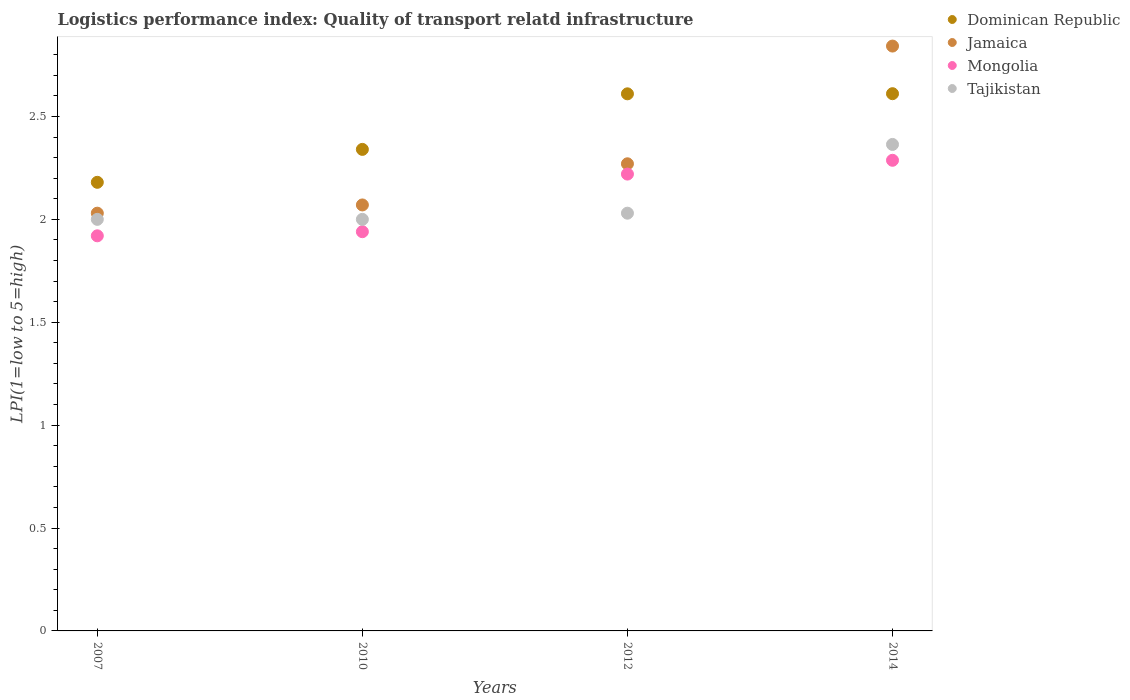How many different coloured dotlines are there?
Keep it short and to the point. 4. Is the number of dotlines equal to the number of legend labels?
Offer a terse response. Yes. What is the logistics performance index in Tajikistan in 2014?
Your answer should be very brief. 2.36. Across all years, what is the maximum logistics performance index in Dominican Republic?
Provide a short and direct response. 2.61. Across all years, what is the minimum logistics performance index in Mongolia?
Offer a very short reply. 1.92. In which year was the logistics performance index in Mongolia maximum?
Your answer should be compact. 2014. In which year was the logistics performance index in Dominican Republic minimum?
Offer a terse response. 2007. What is the total logistics performance index in Jamaica in the graph?
Make the answer very short. 9.21. What is the difference between the logistics performance index in Mongolia in 2007 and that in 2010?
Offer a very short reply. -0.02. What is the difference between the logistics performance index in Dominican Republic in 2014 and the logistics performance index in Jamaica in 2007?
Offer a very short reply. 0.58. What is the average logistics performance index in Jamaica per year?
Your answer should be very brief. 2.3. In the year 2010, what is the difference between the logistics performance index in Dominican Republic and logistics performance index in Tajikistan?
Your answer should be compact. 0.34. In how many years, is the logistics performance index in Tajikistan greater than 0.6?
Make the answer very short. 4. What is the ratio of the logistics performance index in Mongolia in 2007 to that in 2014?
Provide a short and direct response. 0.84. What is the difference between the highest and the second highest logistics performance index in Tajikistan?
Your answer should be compact. 0.33. What is the difference between the highest and the lowest logistics performance index in Tajikistan?
Give a very brief answer. 0.36. In how many years, is the logistics performance index in Tajikistan greater than the average logistics performance index in Tajikistan taken over all years?
Provide a succinct answer. 1. Is the sum of the logistics performance index in Tajikistan in 2007 and 2014 greater than the maximum logistics performance index in Dominican Republic across all years?
Your answer should be compact. Yes. Does the logistics performance index in Tajikistan monotonically increase over the years?
Keep it short and to the point. No. Is the logistics performance index in Dominican Republic strictly greater than the logistics performance index in Tajikistan over the years?
Provide a short and direct response. Yes. How many dotlines are there?
Your response must be concise. 4. Are the values on the major ticks of Y-axis written in scientific E-notation?
Ensure brevity in your answer.  No. Does the graph contain any zero values?
Keep it short and to the point. No. Does the graph contain grids?
Offer a terse response. No. Where does the legend appear in the graph?
Make the answer very short. Top right. What is the title of the graph?
Ensure brevity in your answer.  Logistics performance index: Quality of transport relatd infrastructure. Does "Mali" appear as one of the legend labels in the graph?
Offer a terse response. No. What is the label or title of the X-axis?
Your answer should be very brief. Years. What is the label or title of the Y-axis?
Offer a terse response. LPI(1=low to 5=high). What is the LPI(1=low to 5=high) of Dominican Republic in 2007?
Ensure brevity in your answer.  2.18. What is the LPI(1=low to 5=high) of Jamaica in 2007?
Keep it short and to the point. 2.03. What is the LPI(1=low to 5=high) in Mongolia in 2007?
Your answer should be very brief. 1.92. What is the LPI(1=low to 5=high) of Dominican Republic in 2010?
Make the answer very short. 2.34. What is the LPI(1=low to 5=high) of Jamaica in 2010?
Give a very brief answer. 2.07. What is the LPI(1=low to 5=high) in Mongolia in 2010?
Make the answer very short. 1.94. What is the LPI(1=low to 5=high) of Tajikistan in 2010?
Ensure brevity in your answer.  2. What is the LPI(1=low to 5=high) in Dominican Republic in 2012?
Provide a short and direct response. 2.61. What is the LPI(1=low to 5=high) in Jamaica in 2012?
Your answer should be compact. 2.27. What is the LPI(1=low to 5=high) of Mongolia in 2012?
Your answer should be compact. 2.22. What is the LPI(1=low to 5=high) of Tajikistan in 2012?
Offer a terse response. 2.03. What is the LPI(1=low to 5=high) of Dominican Republic in 2014?
Your answer should be very brief. 2.61. What is the LPI(1=low to 5=high) of Jamaica in 2014?
Offer a terse response. 2.84. What is the LPI(1=low to 5=high) of Mongolia in 2014?
Keep it short and to the point. 2.29. What is the LPI(1=low to 5=high) of Tajikistan in 2014?
Make the answer very short. 2.36. Across all years, what is the maximum LPI(1=low to 5=high) in Dominican Republic?
Provide a succinct answer. 2.61. Across all years, what is the maximum LPI(1=low to 5=high) of Jamaica?
Your answer should be very brief. 2.84. Across all years, what is the maximum LPI(1=low to 5=high) in Mongolia?
Offer a very short reply. 2.29. Across all years, what is the maximum LPI(1=low to 5=high) in Tajikistan?
Offer a very short reply. 2.36. Across all years, what is the minimum LPI(1=low to 5=high) in Dominican Republic?
Keep it short and to the point. 2.18. Across all years, what is the minimum LPI(1=low to 5=high) of Jamaica?
Give a very brief answer. 2.03. Across all years, what is the minimum LPI(1=low to 5=high) of Mongolia?
Your answer should be very brief. 1.92. Across all years, what is the minimum LPI(1=low to 5=high) of Tajikistan?
Provide a short and direct response. 2. What is the total LPI(1=low to 5=high) of Dominican Republic in the graph?
Provide a succinct answer. 9.74. What is the total LPI(1=low to 5=high) of Jamaica in the graph?
Provide a succinct answer. 9.21. What is the total LPI(1=low to 5=high) of Mongolia in the graph?
Ensure brevity in your answer.  8.37. What is the total LPI(1=low to 5=high) in Tajikistan in the graph?
Provide a short and direct response. 8.39. What is the difference between the LPI(1=low to 5=high) in Dominican Republic in 2007 and that in 2010?
Keep it short and to the point. -0.16. What is the difference between the LPI(1=low to 5=high) in Jamaica in 2007 and that in 2010?
Offer a very short reply. -0.04. What is the difference between the LPI(1=low to 5=high) in Mongolia in 2007 and that in 2010?
Provide a short and direct response. -0.02. What is the difference between the LPI(1=low to 5=high) in Dominican Republic in 2007 and that in 2012?
Keep it short and to the point. -0.43. What is the difference between the LPI(1=low to 5=high) of Jamaica in 2007 and that in 2012?
Offer a very short reply. -0.24. What is the difference between the LPI(1=low to 5=high) of Mongolia in 2007 and that in 2012?
Offer a terse response. -0.3. What is the difference between the LPI(1=low to 5=high) in Tajikistan in 2007 and that in 2012?
Your answer should be very brief. -0.03. What is the difference between the LPI(1=low to 5=high) in Dominican Republic in 2007 and that in 2014?
Your answer should be compact. -0.43. What is the difference between the LPI(1=low to 5=high) in Jamaica in 2007 and that in 2014?
Your answer should be very brief. -0.81. What is the difference between the LPI(1=low to 5=high) in Mongolia in 2007 and that in 2014?
Your answer should be compact. -0.37. What is the difference between the LPI(1=low to 5=high) in Tajikistan in 2007 and that in 2014?
Give a very brief answer. -0.36. What is the difference between the LPI(1=low to 5=high) in Dominican Republic in 2010 and that in 2012?
Ensure brevity in your answer.  -0.27. What is the difference between the LPI(1=low to 5=high) of Mongolia in 2010 and that in 2012?
Your answer should be compact. -0.28. What is the difference between the LPI(1=low to 5=high) of Tajikistan in 2010 and that in 2012?
Make the answer very short. -0.03. What is the difference between the LPI(1=low to 5=high) in Dominican Republic in 2010 and that in 2014?
Provide a short and direct response. -0.27. What is the difference between the LPI(1=low to 5=high) in Jamaica in 2010 and that in 2014?
Ensure brevity in your answer.  -0.77. What is the difference between the LPI(1=low to 5=high) in Mongolia in 2010 and that in 2014?
Your answer should be very brief. -0.35. What is the difference between the LPI(1=low to 5=high) of Tajikistan in 2010 and that in 2014?
Give a very brief answer. -0.36. What is the difference between the LPI(1=low to 5=high) in Dominican Republic in 2012 and that in 2014?
Make the answer very short. -0. What is the difference between the LPI(1=low to 5=high) of Jamaica in 2012 and that in 2014?
Provide a succinct answer. -0.57. What is the difference between the LPI(1=low to 5=high) of Mongolia in 2012 and that in 2014?
Give a very brief answer. -0.07. What is the difference between the LPI(1=low to 5=high) of Tajikistan in 2012 and that in 2014?
Provide a succinct answer. -0.33. What is the difference between the LPI(1=low to 5=high) of Dominican Republic in 2007 and the LPI(1=low to 5=high) of Jamaica in 2010?
Ensure brevity in your answer.  0.11. What is the difference between the LPI(1=low to 5=high) of Dominican Republic in 2007 and the LPI(1=low to 5=high) of Mongolia in 2010?
Give a very brief answer. 0.24. What is the difference between the LPI(1=low to 5=high) of Dominican Republic in 2007 and the LPI(1=low to 5=high) of Tajikistan in 2010?
Offer a very short reply. 0.18. What is the difference between the LPI(1=low to 5=high) of Jamaica in 2007 and the LPI(1=low to 5=high) of Mongolia in 2010?
Ensure brevity in your answer.  0.09. What is the difference between the LPI(1=low to 5=high) in Mongolia in 2007 and the LPI(1=low to 5=high) in Tajikistan in 2010?
Give a very brief answer. -0.08. What is the difference between the LPI(1=low to 5=high) in Dominican Republic in 2007 and the LPI(1=low to 5=high) in Jamaica in 2012?
Your answer should be compact. -0.09. What is the difference between the LPI(1=low to 5=high) of Dominican Republic in 2007 and the LPI(1=low to 5=high) of Mongolia in 2012?
Your answer should be very brief. -0.04. What is the difference between the LPI(1=low to 5=high) of Dominican Republic in 2007 and the LPI(1=low to 5=high) of Tajikistan in 2012?
Offer a terse response. 0.15. What is the difference between the LPI(1=low to 5=high) in Jamaica in 2007 and the LPI(1=low to 5=high) in Mongolia in 2012?
Give a very brief answer. -0.19. What is the difference between the LPI(1=low to 5=high) in Mongolia in 2007 and the LPI(1=low to 5=high) in Tajikistan in 2012?
Your response must be concise. -0.11. What is the difference between the LPI(1=low to 5=high) of Dominican Republic in 2007 and the LPI(1=low to 5=high) of Jamaica in 2014?
Your answer should be compact. -0.66. What is the difference between the LPI(1=low to 5=high) in Dominican Republic in 2007 and the LPI(1=low to 5=high) in Mongolia in 2014?
Your answer should be very brief. -0.11. What is the difference between the LPI(1=low to 5=high) in Dominican Republic in 2007 and the LPI(1=low to 5=high) in Tajikistan in 2014?
Offer a very short reply. -0.18. What is the difference between the LPI(1=low to 5=high) in Jamaica in 2007 and the LPI(1=low to 5=high) in Mongolia in 2014?
Your answer should be compact. -0.26. What is the difference between the LPI(1=low to 5=high) in Jamaica in 2007 and the LPI(1=low to 5=high) in Tajikistan in 2014?
Your answer should be compact. -0.33. What is the difference between the LPI(1=low to 5=high) of Mongolia in 2007 and the LPI(1=low to 5=high) of Tajikistan in 2014?
Your answer should be compact. -0.44. What is the difference between the LPI(1=low to 5=high) in Dominican Republic in 2010 and the LPI(1=low to 5=high) in Jamaica in 2012?
Your answer should be very brief. 0.07. What is the difference between the LPI(1=low to 5=high) in Dominican Republic in 2010 and the LPI(1=low to 5=high) in Mongolia in 2012?
Ensure brevity in your answer.  0.12. What is the difference between the LPI(1=low to 5=high) in Dominican Republic in 2010 and the LPI(1=low to 5=high) in Tajikistan in 2012?
Give a very brief answer. 0.31. What is the difference between the LPI(1=low to 5=high) in Jamaica in 2010 and the LPI(1=low to 5=high) in Tajikistan in 2012?
Provide a succinct answer. 0.04. What is the difference between the LPI(1=low to 5=high) of Mongolia in 2010 and the LPI(1=low to 5=high) of Tajikistan in 2012?
Provide a short and direct response. -0.09. What is the difference between the LPI(1=low to 5=high) in Dominican Republic in 2010 and the LPI(1=low to 5=high) in Jamaica in 2014?
Make the answer very short. -0.5. What is the difference between the LPI(1=low to 5=high) in Dominican Republic in 2010 and the LPI(1=low to 5=high) in Mongolia in 2014?
Offer a terse response. 0.05. What is the difference between the LPI(1=low to 5=high) of Dominican Republic in 2010 and the LPI(1=low to 5=high) of Tajikistan in 2014?
Ensure brevity in your answer.  -0.02. What is the difference between the LPI(1=low to 5=high) of Jamaica in 2010 and the LPI(1=low to 5=high) of Mongolia in 2014?
Offer a terse response. -0.22. What is the difference between the LPI(1=low to 5=high) in Jamaica in 2010 and the LPI(1=low to 5=high) in Tajikistan in 2014?
Your response must be concise. -0.29. What is the difference between the LPI(1=low to 5=high) in Mongolia in 2010 and the LPI(1=low to 5=high) in Tajikistan in 2014?
Offer a terse response. -0.42. What is the difference between the LPI(1=low to 5=high) in Dominican Republic in 2012 and the LPI(1=low to 5=high) in Jamaica in 2014?
Ensure brevity in your answer.  -0.23. What is the difference between the LPI(1=low to 5=high) of Dominican Republic in 2012 and the LPI(1=low to 5=high) of Mongolia in 2014?
Provide a succinct answer. 0.32. What is the difference between the LPI(1=low to 5=high) in Dominican Republic in 2012 and the LPI(1=low to 5=high) in Tajikistan in 2014?
Your answer should be compact. 0.25. What is the difference between the LPI(1=low to 5=high) in Jamaica in 2012 and the LPI(1=low to 5=high) in Mongolia in 2014?
Make the answer very short. -0.02. What is the difference between the LPI(1=low to 5=high) of Jamaica in 2012 and the LPI(1=low to 5=high) of Tajikistan in 2014?
Give a very brief answer. -0.09. What is the difference between the LPI(1=low to 5=high) of Mongolia in 2012 and the LPI(1=low to 5=high) of Tajikistan in 2014?
Keep it short and to the point. -0.14. What is the average LPI(1=low to 5=high) of Dominican Republic per year?
Provide a short and direct response. 2.44. What is the average LPI(1=low to 5=high) of Jamaica per year?
Provide a succinct answer. 2.3. What is the average LPI(1=low to 5=high) of Mongolia per year?
Your response must be concise. 2.09. What is the average LPI(1=low to 5=high) of Tajikistan per year?
Make the answer very short. 2.1. In the year 2007, what is the difference between the LPI(1=low to 5=high) of Dominican Republic and LPI(1=low to 5=high) of Jamaica?
Give a very brief answer. 0.15. In the year 2007, what is the difference between the LPI(1=low to 5=high) of Dominican Republic and LPI(1=low to 5=high) of Mongolia?
Keep it short and to the point. 0.26. In the year 2007, what is the difference between the LPI(1=low to 5=high) in Dominican Republic and LPI(1=low to 5=high) in Tajikistan?
Provide a short and direct response. 0.18. In the year 2007, what is the difference between the LPI(1=low to 5=high) in Jamaica and LPI(1=low to 5=high) in Mongolia?
Provide a succinct answer. 0.11. In the year 2007, what is the difference between the LPI(1=low to 5=high) in Mongolia and LPI(1=low to 5=high) in Tajikistan?
Make the answer very short. -0.08. In the year 2010, what is the difference between the LPI(1=low to 5=high) of Dominican Republic and LPI(1=low to 5=high) of Jamaica?
Keep it short and to the point. 0.27. In the year 2010, what is the difference between the LPI(1=low to 5=high) of Dominican Republic and LPI(1=low to 5=high) of Mongolia?
Offer a terse response. 0.4. In the year 2010, what is the difference between the LPI(1=low to 5=high) of Dominican Republic and LPI(1=low to 5=high) of Tajikistan?
Make the answer very short. 0.34. In the year 2010, what is the difference between the LPI(1=low to 5=high) of Jamaica and LPI(1=low to 5=high) of Mongolia?
Provide a short and direct response. 0.13. In the year 2010, what is the difference between the LPI(1=low to 5=high) of Jamaica and LPI(1=low to 5=high) of Tajikistan?
Ensure brevity in your answer.  0.07. In the year 2010, what is the difference between the LPI(1=low to 5=high) of Mongolia and LPI(1=low to 5=high) of Tajikistan?
Offer a very short reply. -0.06. In the year 2012, what is the difference between the LPI(1=low to 5=high) in Dominican Republic and LPI(1=low to 5=high) in Jamaica?
Provide a succinct answer. 0.34. In the year 2012, what is the difference between the LPI(1=low to 5=high) in Dominican Republic and LPI(1=low to 5=high) in Mongolia?
Your response must be concise. 0.39. In the year 2012, what is the difference between the LPI(1=low to 5=high) of Dominican Republic and LPI(1=low to 5=high) of Tajikistan?
Provide a succinct answer. 0.58. In the year 2012, what is the difference between the LPI(1=low to 5=high) in Jamaica and LPI(1=low to 5=high) in Tajikistan?
Your response must be concise. 0.24. In the year 2012, what is the difference between the LPI(1=low to 5=high) in Mongolia and LPI(1=low to 5=high) in Tajikistan?
Make the answer very short. 0.19. In the year 2014, what is the difference between the LPI(1=low to 5=high) of Dominican Republic and LPI(1=low to 5=high) of Jamaica?
Your answer should be very brief. -0.23. In the year 2014, what is the difference between the LPI(1=low to 5=high) of Dominican Republic and LPI(1=low to 5=high) of Mongolia?
Your response must be concise. 0.32. In the year 2014, what is the difference between the LPI(1=low to 5=high) in Dominican Republic and LPI(1=low to 5=high) in Tajikistan?
Your response must be concise. 0.25. In the year 2014, what is the difference between the LPI(1=low to 5=high) in Jamaica and LPI(1=low to 5=high) in Mongolia?
Make the answer very short. 0.56. In the year 2014, what is the difference between the LPI(1=low to 5=high) of Jamaica and LPI(1=low to 5=high) of Tajikistan?
Ensure brevity in your answer.  0.48. In the year 2014, what is the difference between the LPI(1=low to 5=high) of Mongolia and LPI(1=low to 5=high) of Tajikistan?
Make the answer very short. -0.08. What is the ratio of the LPI(1=low to 5=high) of Dominican Republic in 2007 to that in 2010?
Your answer should be compact. 0.93. What is the ratio of the LPI(1=low to 5=high) in Jamaica in 2007 to that in 2010?
Keep it short and to the point. 0.98. What is the ratio of the LPI(1=low to 5=high) of Mongolia in 2007 to that in 2010?
Keep it short and to the point. 0.99. What is the ratio of the LPI(1=low to 5=high) in Dominican Republic in 2007 to that in 2012?
Your answer should be very brief. 0.84. What is the ratio of the LPI(1=low to 5=high) of Jamaica in 2007 to that in 2012?
Ensure brevity in your answer.  0.89. What is the ratio of the LPI(1=low to 5=high) of Mongolia in 2007 to that in 2012?
Make the answer very short. 0.86. What is the ratio of the LPI(1=low to 5=high) of Tajikistan in 2007 to that in 2012?
Keep it short and to the point. 0.99. What is the ratio of the LPI(1=low to 5=high) of Dominican Republic in 2007 to that in 2014?
Your answer should be very brief. 0.83. What is the ratio of the LPI(1=low to 5=high) of Mongolia in 2007 to that in 2014?
Your answer should be compact. 0.84. What is the ratio of the LPI(1=low to 5=high) in Tajikistan in 2007 to that in 2014?
Offer a terse response. 0.85. What is the ratio of the LPI(1=low to 5=high) in Dominican Republic in 2010 to that in 2012?
Give a very brief answer. 0.9. What is the ratio of the LPI(1=low to 5=high) of Jamaica in 2010 to that in 2012?
Your answer should be compact. 0.91. What is the ratio of the LPI(1=low to 5=high) in Mongolia in 2010 to that in 2012?
Offer a very short reply. 0.87. What is the ratio of the LPI(1=low to 5=high) in Tajikistan in 2010 to that in 2012?
Keep it short and to the point. 0.99. What is the ratio of the LPI(1=low to 5=high) in Dominican Republic in 2010 to that in 2014?
Your answer should be compact. 0.9. What is the ratio of the LPI(1=low to 5=high) in Jamaica in 2010 to that in 2014?
Give a very brief answer. 0.73. What is the ratio of the LPI(1=low to 5=high) in Mongolia in 2010 to that in 2014?
Your answer should be compact. 0.85. What is the ratio of the LPI(1=low to 5=high) of Tajikistan in 2010 to that in 2014?
Your response must be concise. 0.85. What is the ratio of the LPI(1=low to 5=high) of Jamaica in 2012 to that in 2014?
Provide a short and direct response. 0.8. What is the ratio of the LPI(1=low to 5=high) in Mongolia in 2012 to that in 2014?
Offer a terse response. 0.97. What is the ratio of the LPI(1=low to 5=high) of Tajikistan in 2012 to that in 2014?
Ensure brevity in your answer.  0.86. What is the difference between the highest and the second highest LPI(1=low to 5=high) of Dominican Republic?
Provide a short and direct response. 0. What is the difference between the highest and the second highest LPI(1=low to 5=high) of Jamaica?
Make the answer very short. 0.57. What is the difference between the highest and the second highest LPI(1=low to 5=high) in Mongolia?
Your answer should be very brief. 0.07. What is the difference between the highest and the second highest LPI(1=low to 5=high) of Tajikistan?
Your answer should be very brief. 0.33. What is the difference between the highest and the lowest LPI(1=low to 5=high) in Dominican Republic?
Ensure brevity in your answer.  0.43. What is the difference between the highest and the lowest LPI(1=low to 5=high) in Jamaica?
Your response must be concise. 0.81. What is the difference between the highest and the lowest LPI(1=low to 5=high) in Mongolia?
Your answer should be very brief. 0.37. What is the difference between the highest and the lowest LPI(1=low to 5=high) of Tajikistan?
Give a very brief answer. 0.36. 